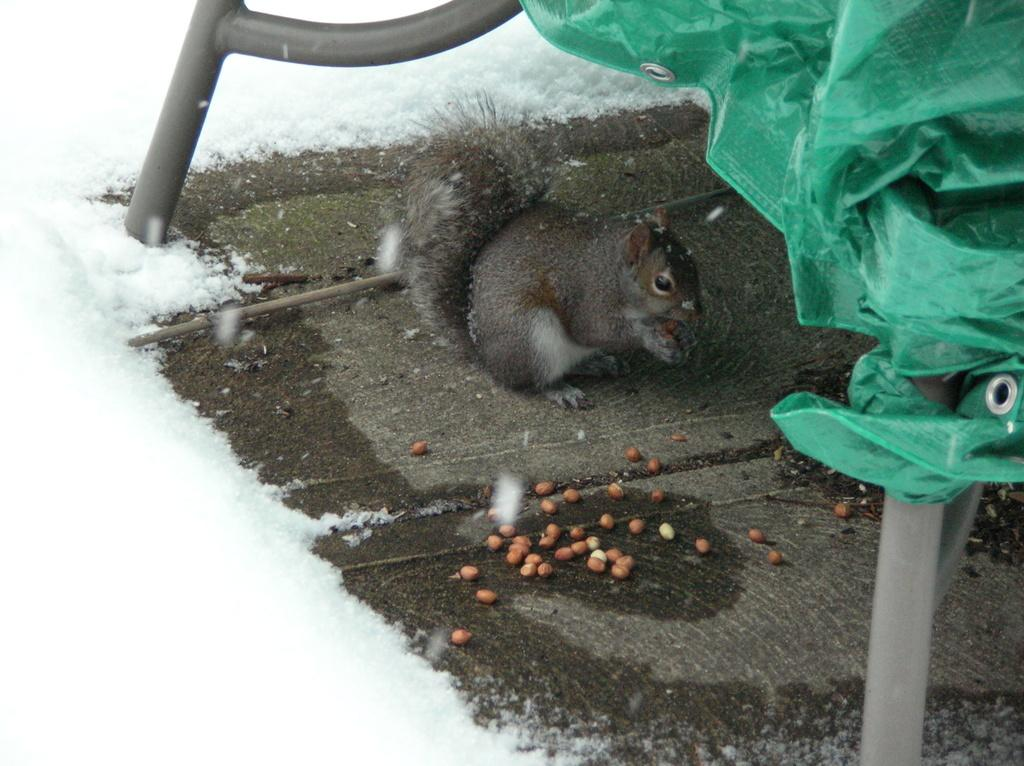What is on the floor in the image? There is a squeal with nuts on the floor. Can you describe the environment in the image? The image shows a snowy environment. What type of wing can be seen on the giraffe in the image? There is no giraffe or wing present in the image; it only features a squeal with nuts on the floor in a snowy environment. 